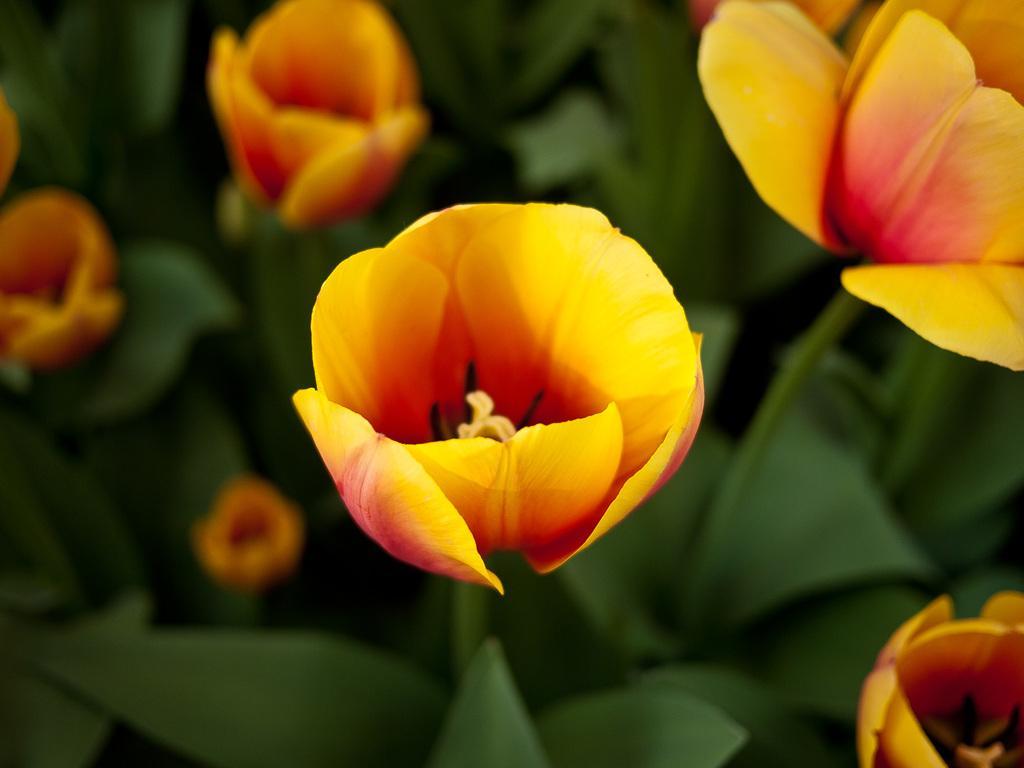Can you describe this image briefly? In this image we can see flowers. In the background there are leaves. 